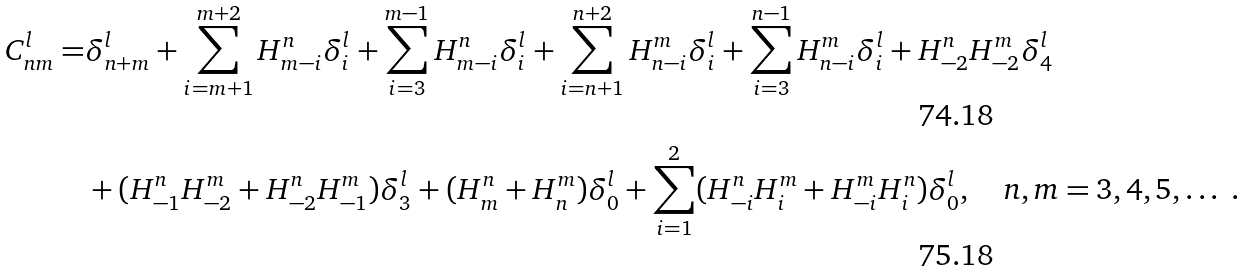Convert formula to latex. <formula><loc_0><loc_0><loc_500><loc_500>C ^ { l } _ { n m } = & \delta _ { n + m } ^ { l } + \sum _ { i = m + 1 } ^ { m + 2 } H ^ { n } _ { m - i } \delta _ { i } ^ { l } + \sum _ { i = 3 } ^ { m - 1 } H ^ { n } _ { m - i } \delta _ { i } ^ { l } + \sum _ { i = n + 1 } ^ { n + 2 } H ^ { m } _ { n - i } \delta _ { i } ^ { l } + \sum _ { i = 3 } ^ { n - 1 } H ^ { m } _ { n - i } \delta _ { i } ^ { l } + H ^ { n } _ { - 2 } H ^ { m } _ { - 2 } \delta _ { 4 } ^ { l } \\ & + ( H ^ { n } _ { - 1 } H ^ { m } _ { - 2 } + H ^ { n } _ { - 2 } H ^ { m } _ { - 1 } ) \delta _ { 3 } ^ { l } + ( H ^ { n } _ { m } + H ^ { m } _ { n } ) \delta _ { 0 } ^ { l } + \sum _ { i = 1 } ^ { 2 } ( H ^ { n } _ { - i } H ^ { m } _ { i } + H ^ { m } _ { - i } H ^ { n } _ { i } ) \delta _ { 0 } ^ { l } , \quad n , m = 3 , 4 , 5 , \dots \ .</formula> 